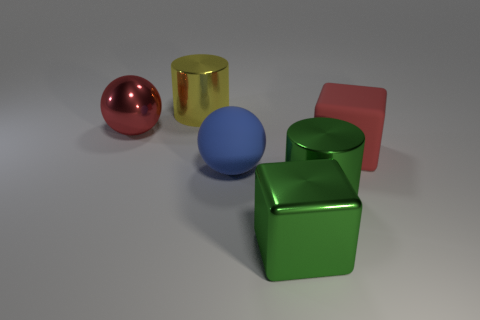Add 4 big red matte balls. How many objects exist? 10 Subtract all red spheres. How many spheres are left? 1 Subtract 2 cylinders. How many cylinders are left? 0 Add 2 red rubber objects. How many red rubber objects exist? 3 Subtract 1 green blocks. How many objects are left? 5 Subtract all cubes. How many objects are left? 4 Subtract all green cylinders. Subtract all blue balls. How many cylinders are left? 1 Subtract all red blocks. How many yellow balls are left? 0 Subtract all big yellow balls. Subtract all big matte spheres. How many objects are left? 5 Add 2 big red rubber things. How many big red rubber things are left? 3 